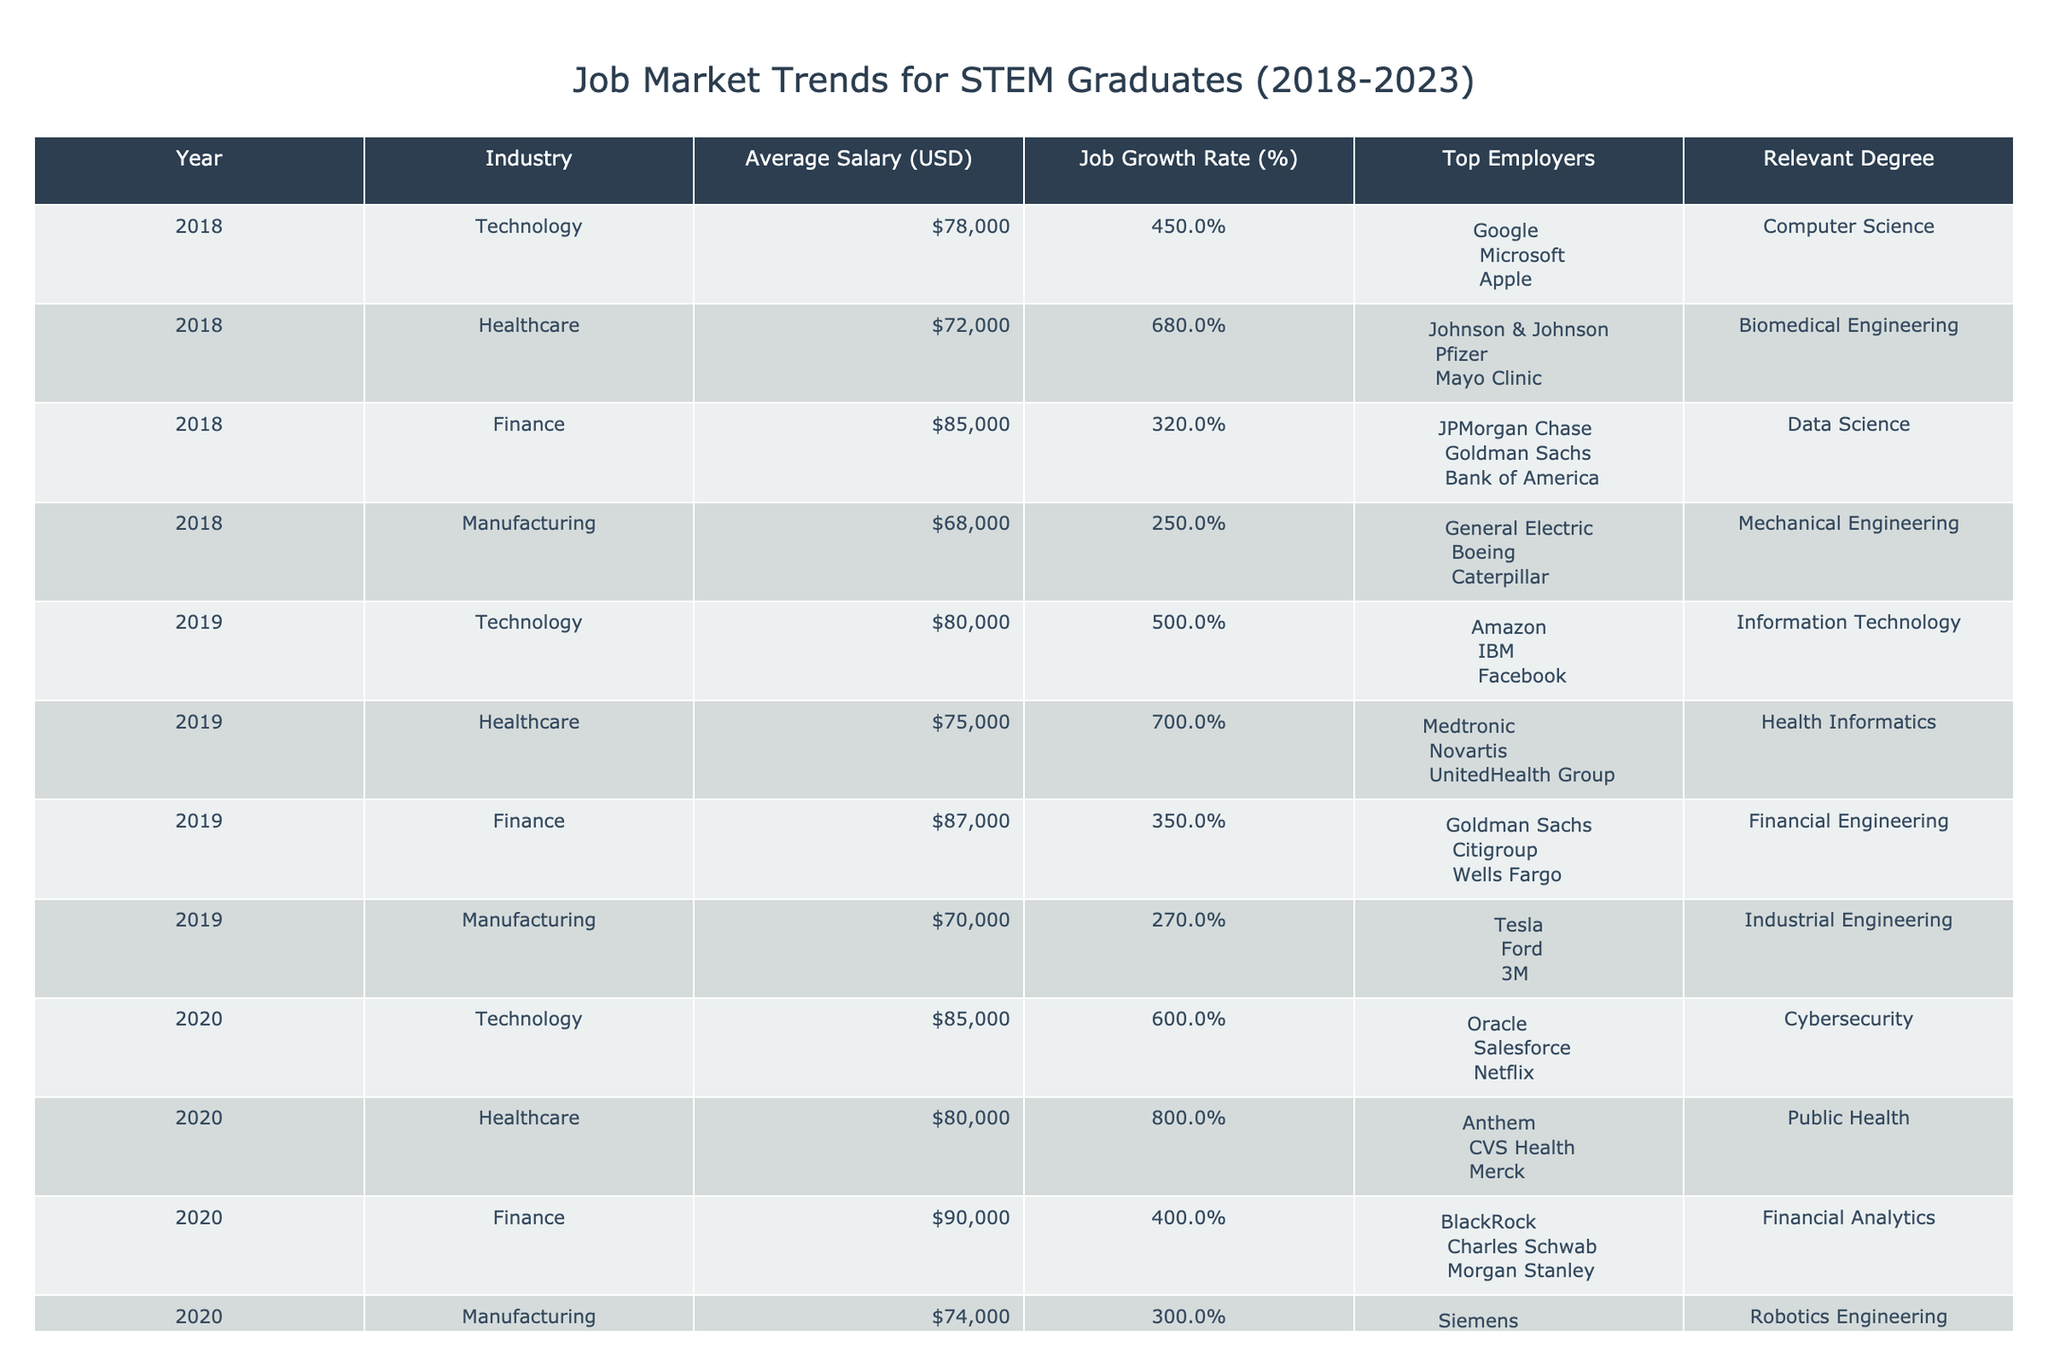What was the average salary for STEM graduates in the Technology sector in 2022? To find the average salary for the Technology sector in 2022, we look for the row corresponding to Technology in 2022, which shows an average salary of 93,000 USD.
Answer: 93,000 USD Which industry had the highest job growth rate in 2021? In 2021, we can compare the job growth rates across all industries. The Healthcare industry had a job growth rate of 8.5%, which is the highest among all.
Answer: Healthcare What is the difference in average salaries between Finance and Manufacturing in 2019? The average salary for Finance in 2019 is 87,000 USD, and for Manufacturing, it is 70,000 USD. Subtracting gives us a difference of 87,000 - 70,000 = 17,000 USD.
Answer: 17,000 USD Did the average salary for Healthcare graduates increase every year from 2018 to 2023? Checking the average salaries for Healthcare from 2018 (72,000 USD) to 2023 (91,000 USD), I can confirm the amounts increased each year: 72,000 → 75,000 → 80,000 → 85,000 → 88,000 → 91,000. Therefore, the statement is true.
Answer: Yes What are the top three employers in the Manufacturing sector for 2020? Looking at the table for Manufacturing in 2020, the top employers listed are Siemens, Honeywell, and Lockheed Martin.
Answer: Siemens, Honeywell, Lockheed Martin Which industry showed the least growth rate in 2018? Analyzing the job growth rates for all industries in 2018, the Manufacturing sector had the lowest growth rate at 2.5%.
Answer: Manufacturing Calculate the average job growth rate for Technology from 2018 to 2023. Collecting the job growth rates for Technology over these years: 4.5%, 5.0%, 6.0%, 7.0%, 7.5%, and 8.0%. The sum is 38% (4.5 + 5.0 + 6.0 + 7.0 + 7.5 + 8.0) and the average is 38/6 = 6.33%.
Answer: 6.33% Was the average salary for Finance graduates lower than that for Healthcare graduates in 2020? In 2020, the average salary for Finance was 90,000 USD, while for Healthcare it was 80,000 USD. Therefore, the average salary for Finance was higher than that of Healthcare.
Answer: No Which industry had the highest average salary in 2023? Checking the salaries for all industries in 2023, Finance had the highest average salary of 101,000 USD compared to Technology (97,000 USD), Healthcare (91,000 USD), and Manufacturing (85,000 USD).
Answer: Finance 